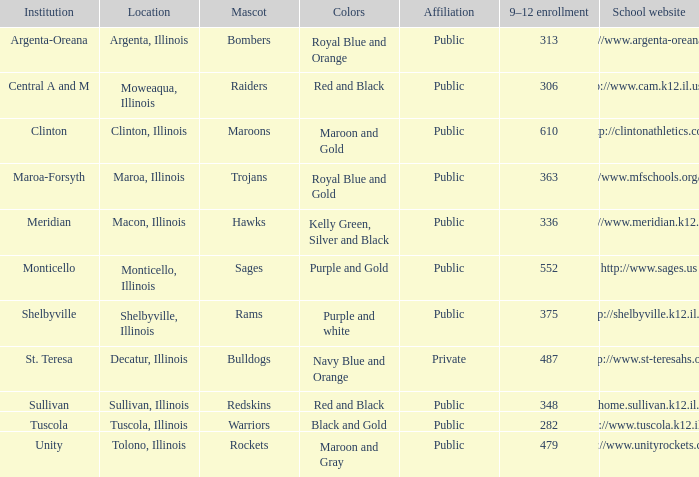What's the name of the city or town of the school that operates the http://www.mfschools.org/high/ website? Maroa-Forsyth. 